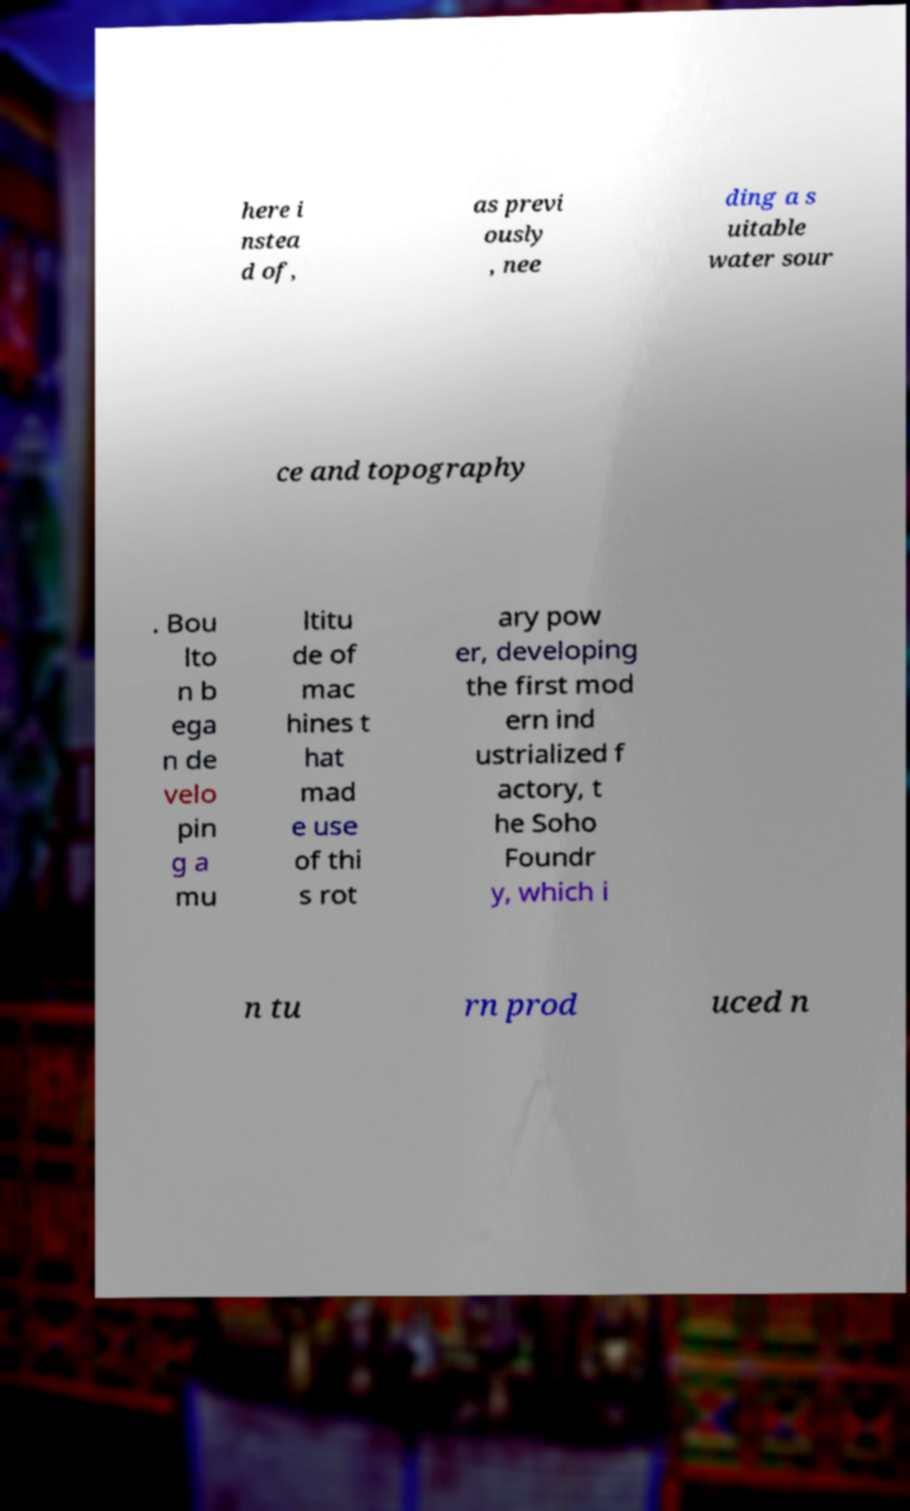There's text embedded in this image that I need extracted. Can you transcribe it verbatim? here i nstea d of, as previ ously , nee ding a s uitable water sour ce and topography . Bou lto n b ega n de velo pin g a mu ltitu de of mac hines t hat mad e use of thi s rot ary pow er, developing the first mod ern ind ustrialized f actory, t he Soho Foundr y, which i n tu rn prod uced n 